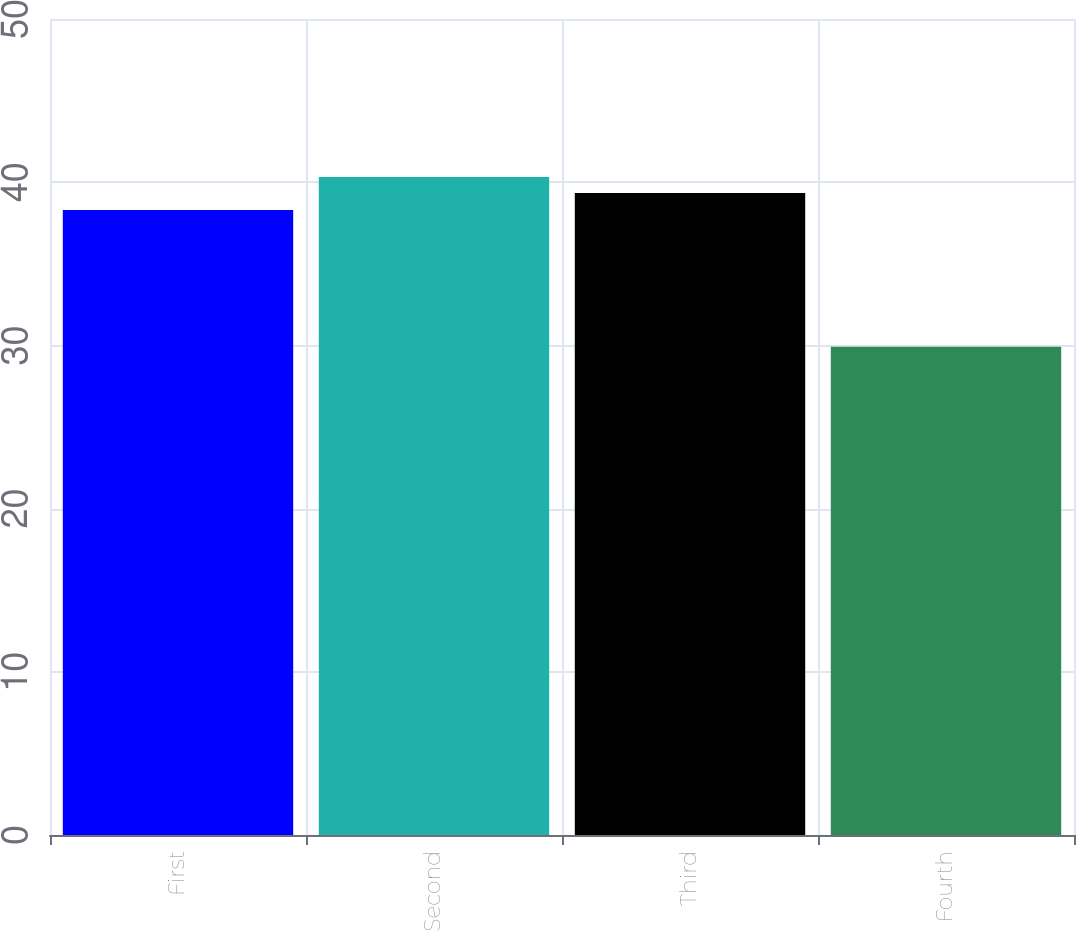Convert chart to OTSL. <chart><loc_0><loc_0><loc_500><loc_500><bar_chart><fcel>First<fcel>Second<fcel>Third<fcel>Fourth<nl><fcel>38.3<fcel>40.32<fcel>39.34<fcel>29.92<nl></chart> 